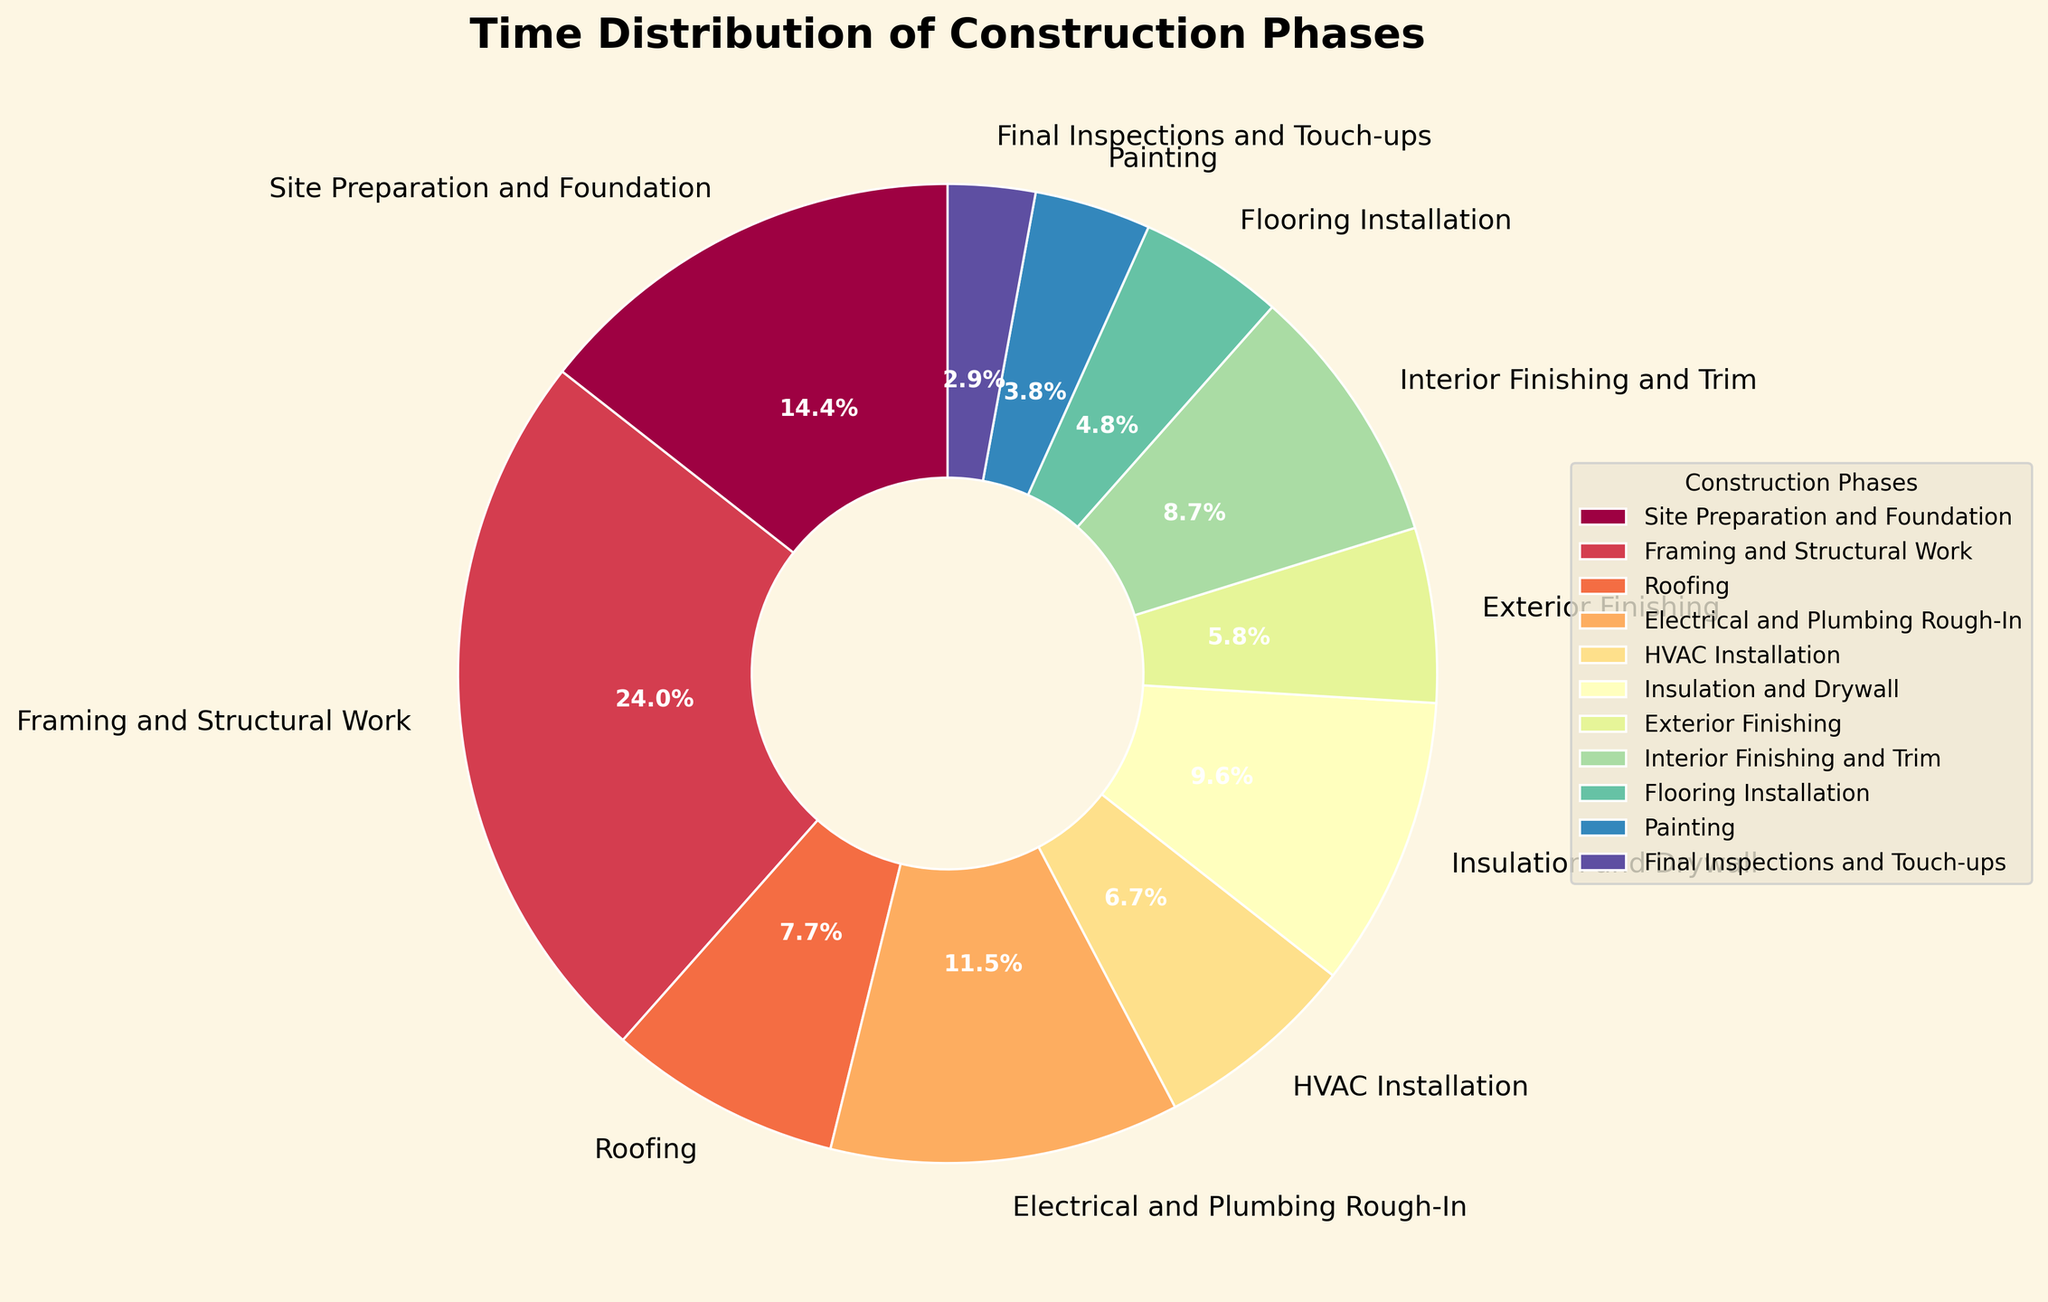What is the total percentage of time spent on Site Preparation and Foundation, Framing and Structural Work, and Roofing? Add the percentages of these phases: Site Preparation and Foundation (15%), Framing and Structural Work (25%), and Roofing (8%). The total percentage is 15 + 25 + 8 = 48%.
Answer: 48% Which phase takes up more time, HVAC Installation or Interior Finishing and Trim? Compare the percentages of HVAC Installation (7%) and Interior Finishing and Trim (9%). Interior Finishing and Trim has the higher percentage.
Answer: Interior Finishing and Trim What is the percentage difference between Electrical and Plumbing Rough-In and Painting? Subtract the percentage of Painting (4%) from Electrical and Plumbing Rough-In (12%). The difference is 12 - 4 = 8%.
Answer: 8% Which phase has the smallest time allocation? Look for the phase with the smallest percentage on the pie chart. Final Inspections and Touch-ups has the smallest percentage at 3%.
Answer: Final Inspections and Touch-ups What is the combined percentage of time for Insulation and Drywall, Exterior Finishing, and Flooring Installation? Add the percentages of Insulation and Drywall (10%), Exterior Finishing (6%), and Flooring Installation (5%). The combined percentage is 10 + 6 + 5 = 21%.
Answer: 21% Is the time spent on Electrical and Plumbing Rough-In greater than the time spent on Painting, Final Inspections and Touch-ups, and Roofing combined? Add the percentages for Painting (4%), Final Inspections and Touch-ups (3%), and Roofing (8%) which gives 4 + 3 + 8 = 15%. Electrical and Plumbing Rough-In is 12%. Compare 12% to 15%. Electrical and Plumbing Rough-In is less than the combined total.
Answer: No Which is higher: the sum of Insulation and Drywall, and Exterior Finishing or the time for Framing and Structural Work? Sum the percentages of Insulation and Drywall (10%) and Exterior Finishing (6%) which gives 10 + 6 = 16%. Compare this to Framing and Structural Work (25%). Framing and Structural Work is higher.
Answer: Framing and Structural Work What is the average percentage of time spent on HVAC Installation, Interior Finishing and Trim, and Flooring Installation? Add the percentages: HVAC Installation (7%), Interior Finishing and Trim (9%), and Flooring Installation (5%). The total is 7 + 9 + 5 = 21%. The average is 21 / 3 = 7%.
Answer: 7% Which phase uses up more time: Insulation and Drywall, or the combined phases of Painting and Final Inspections and Touch-ups? Combine the percentages of Painting (4%) and Final Inspections and Touch-ups (3%) which gives 4 + 3 = 7%. Compare this with Insulation and Drywall (10%). Insulation and Drywall uses up more time.
Answer: Insulation and Drywall Which phase has the largest slice on the pie chart? Observe the pie chart to locate the phase with the largest slice. The phase with the largest slice is Framing and Structural Work at 25%.
Answer: Framing and Structural Work 